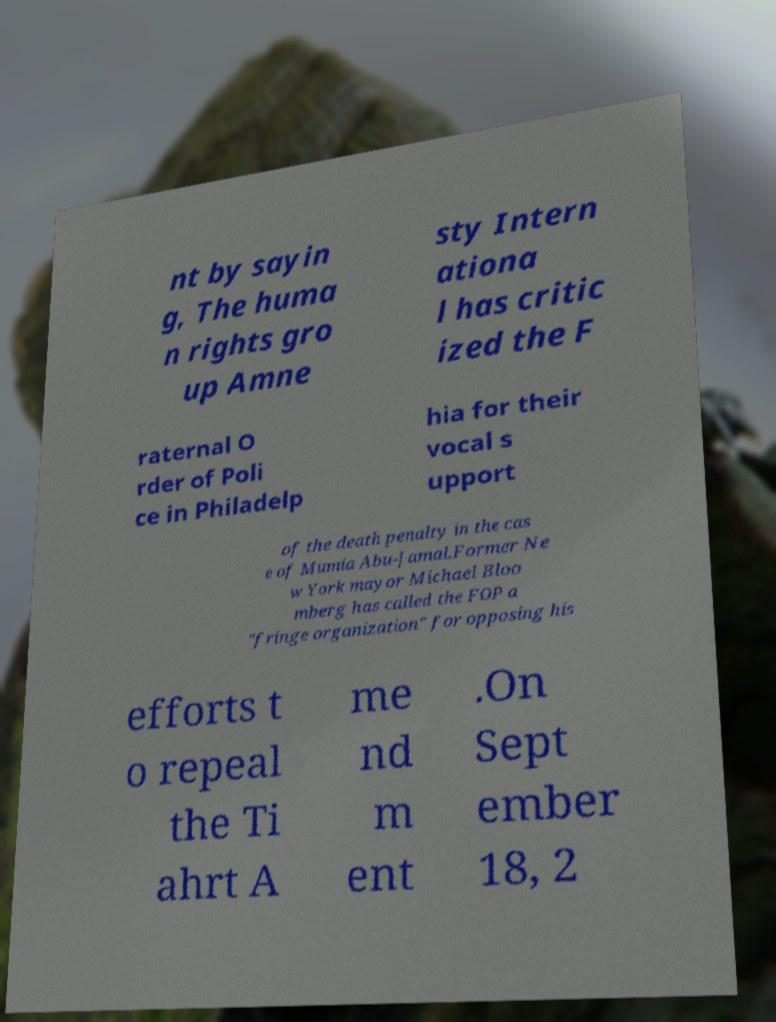Please read and relay the text visible in this image. What does it say? nt by sayin g, The huma n rights gro up Amne sty Intern ationa l has critic ized the F raternal O rder of Poli ce in Philadelp hia for their vocal s upport of the death penalty in the cas e of Mumia Abu-Jamal.Former Ne w York mayor Michael Bloo mberg has called the FOP a "fringe organization" for opposing his efforts t o repeal the Ti ahrt A me nd m ent .On Sept ember 18, 2 